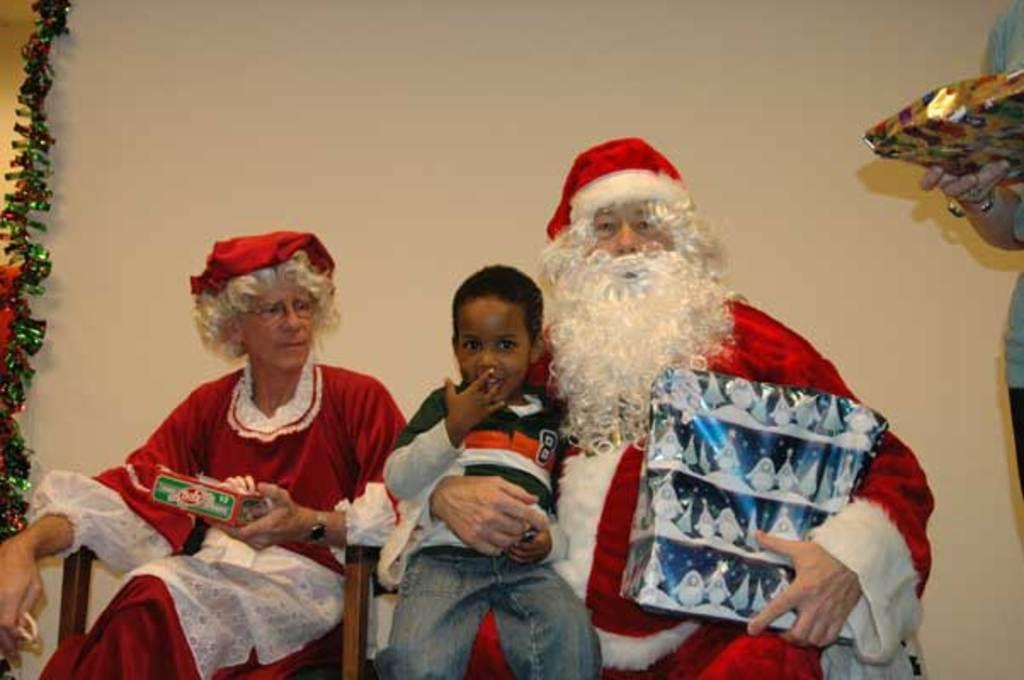In one or two sentences, can you explain what this image depicts? In this image there is a Santa Claus on the right side who is holding the gift box with one hand and a boy with another hand. Beside him there is a woman who is sitting in the chair by holding the cookies. On the right side there is a person standing on the floor by holding the box. On the left side there are some decorative items. 